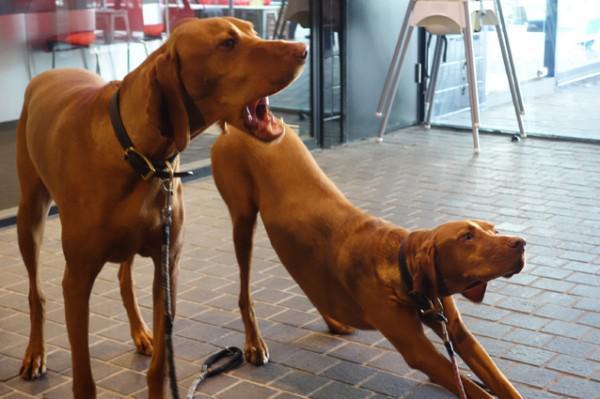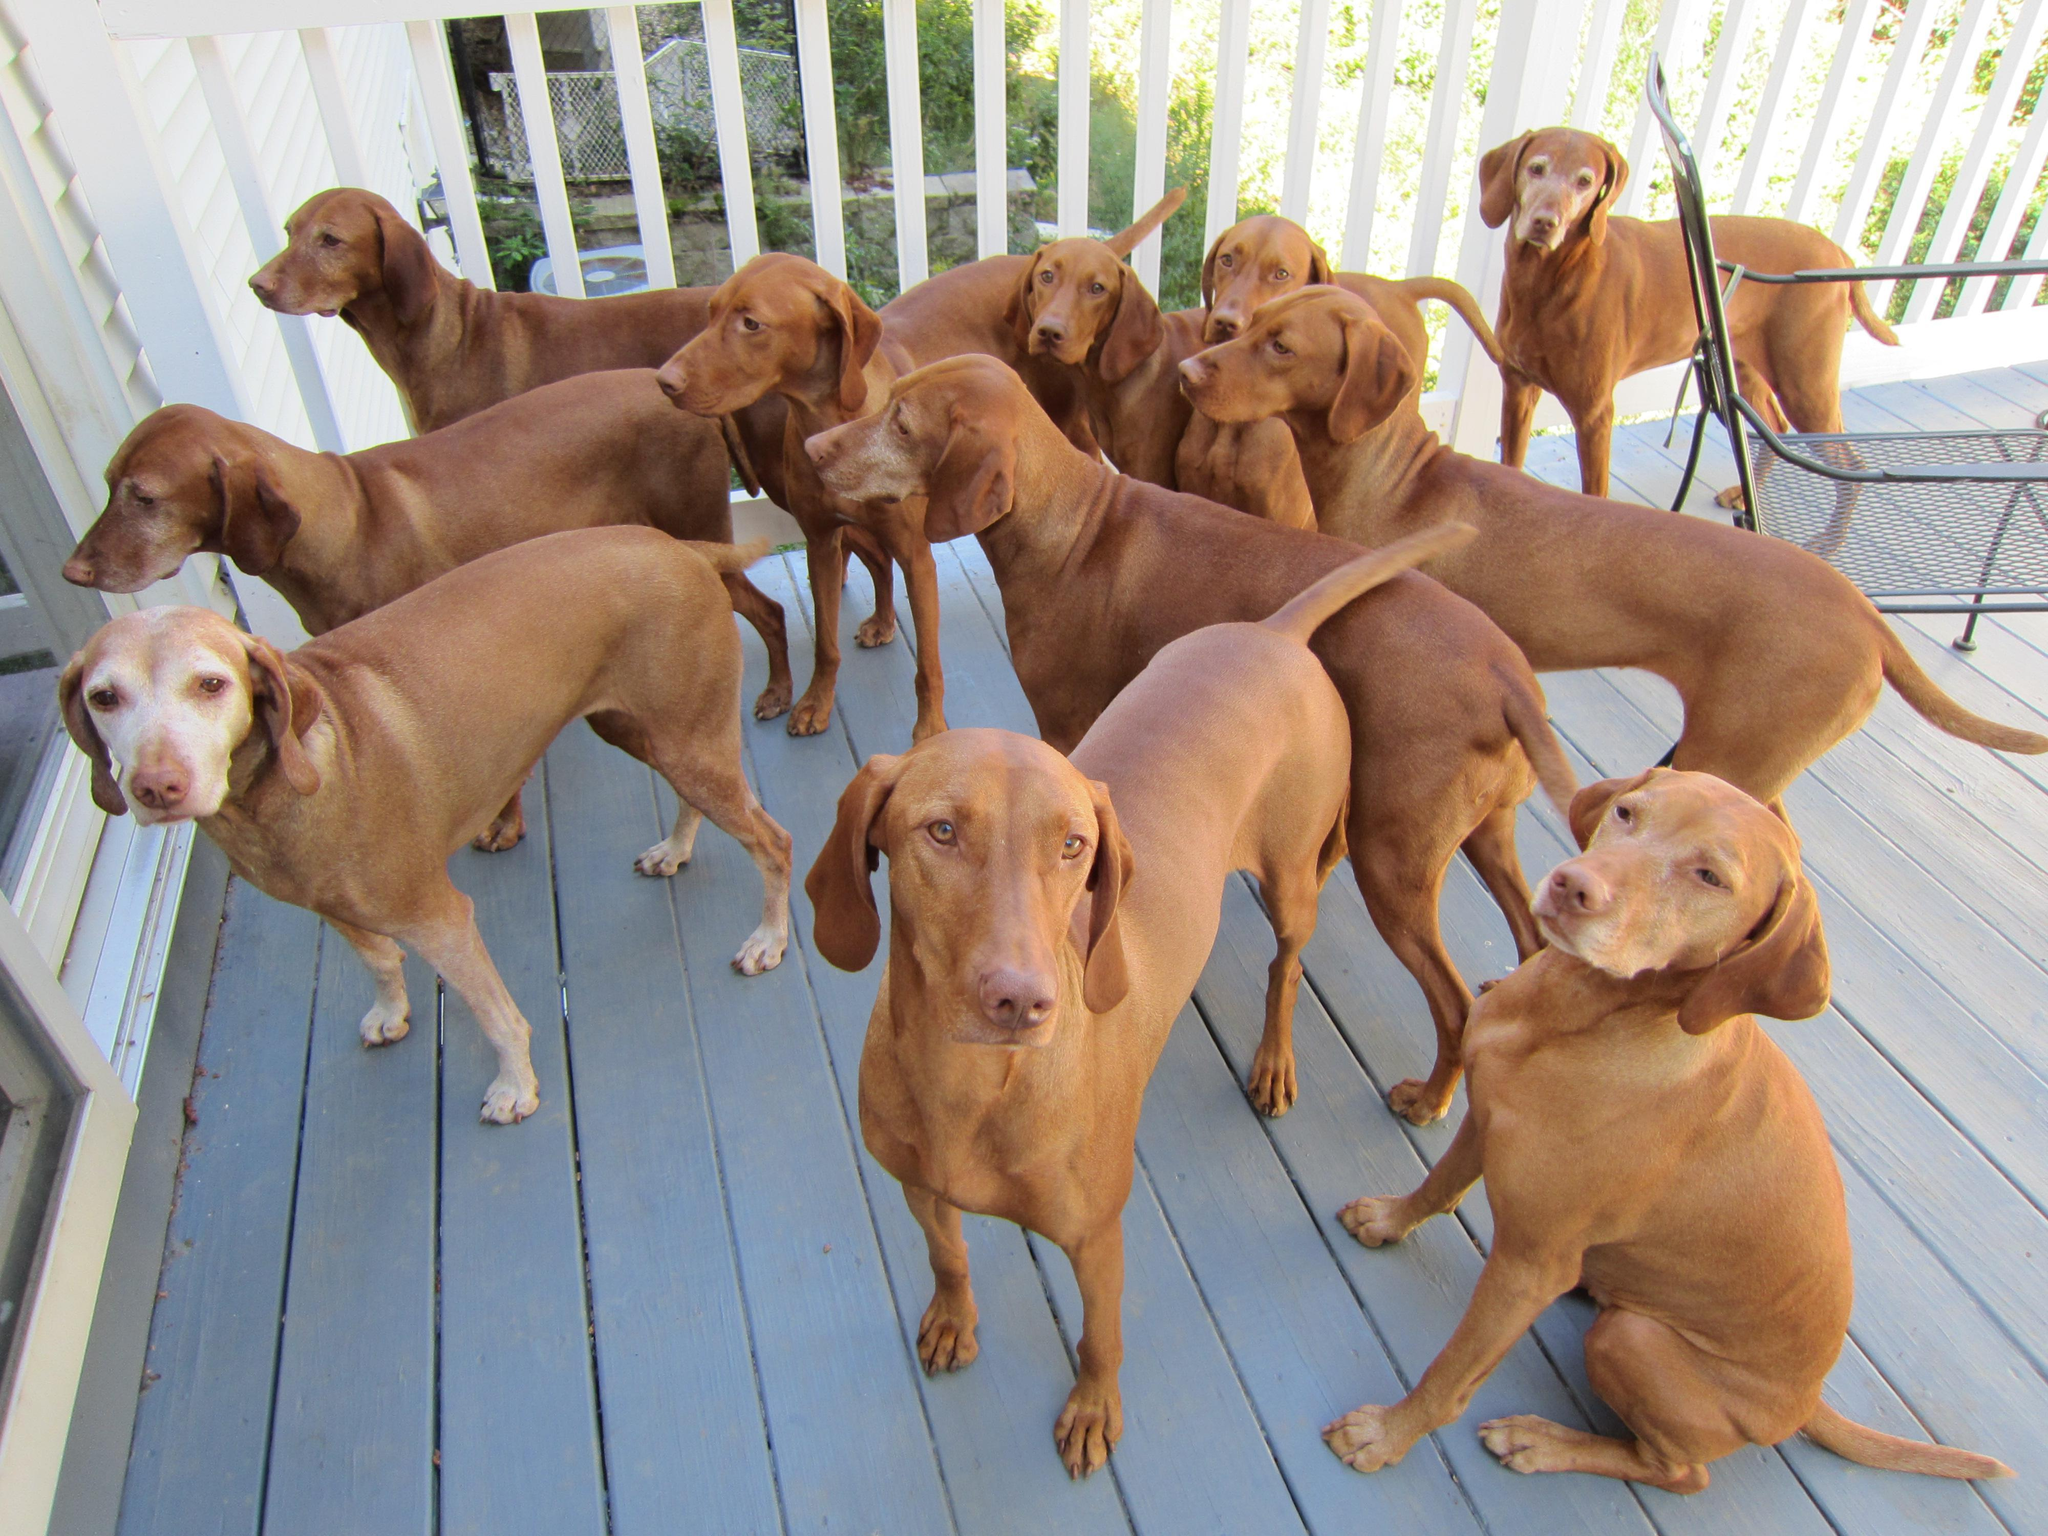The first image is the image on the left, the second image is the image on the right. Assess this claim about the two images: "One image shows two dogs with the same coloring sitting side-by-side with their chests facing the camera, and the other image shows one dog in a standing pose outdoors.". Correct or not? Answer yes or no. No. The first image is the image on the left, the second image is the image on the right. For the images shown, is this caption "The left image contains exactly two dogs." true? Answer yes or no. Yes. 